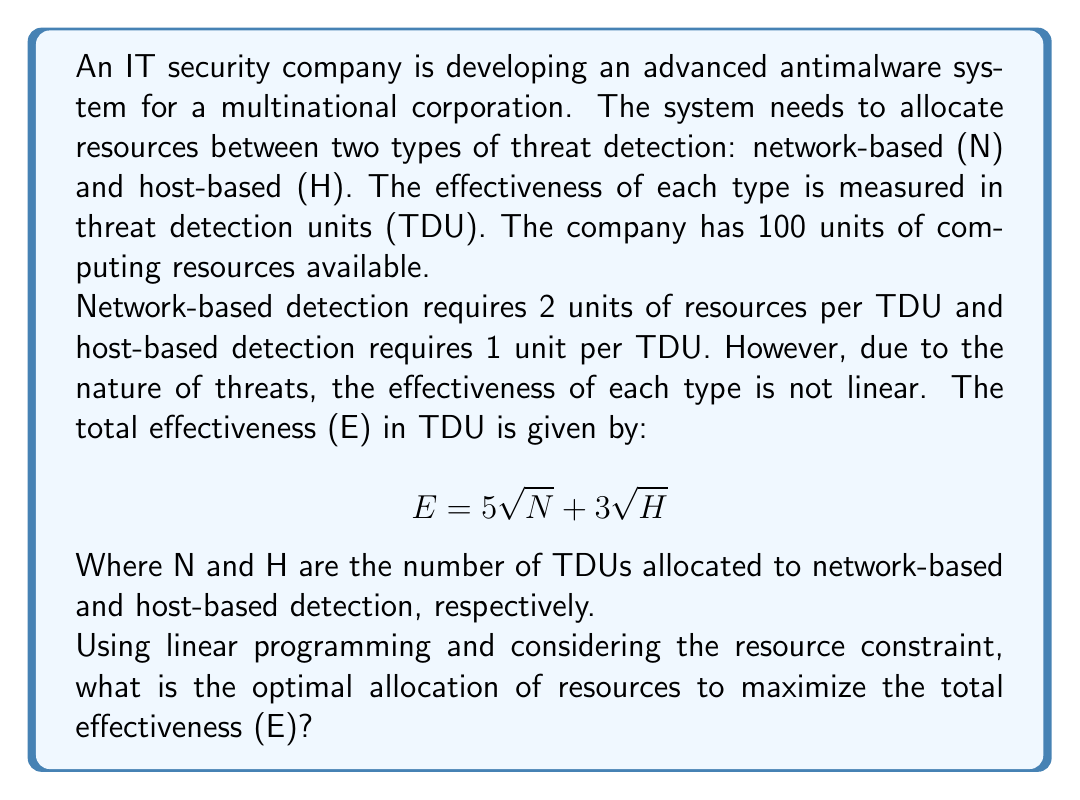Provide a solution to this math problem. To solve this problem, we need to formulate it as a linear programming problem and then solve it. Let's approach this step-by-step:

1) First, let's define our variables:
   N = number of TDUs for network-based detection
   H = number of TDUs for host-based detection

2) Our objective function is:
   $$ E = 5\sqrt{N} + 3\sqrt{H} $$

3) Our constraint is:
   $$ 2N + H \leq 100 $$
   (because network-based detection uses 2 units per TDU, host-based uses 1 unit, and total resources are 100)

4) We also have non-negativity constraints:
   $$ N \geq 0, H \geq 0 $$

5) This is not a linear programming problem yet because of the square roots. To linearize it, we can introduce new variables:
   Let $x = \sqrt{N}$ and $y = \sqrt{H}$

6) Now our problem becomes:
   Maximize $E = 5x + 3y$
   Subject to: $2x^2 + y^2 \leq 100$
               $x \geq 0, y \geq 0$

7) This is now a nonlinear programming problem. We can solve it using the method of Lagrange multipliers:

   $L(x,y,\lambda) = 5x + 3y + \lambda(100 - 2x^2 - y^2)$

8) Taking partial derivatives and setting them to zero:

   $\frac{\partial L}{\partial x} = 5 - 4\lambda x = 0$
   $\frac{\partial L}{\partial y} = 3 - 2\lambda y = 0$
   $\frac{\partial L}{\partial \lambda} = 100 - 2x^2 - y^2 = 0$

9) From the first two equations:
   $x = \frac{5}{4\lambda}$ and $y = \frac{3}{2\lambda}$

10) Substituting these into the third equation:

    $100 - 2(\frac{5}{4\lambda})^2 - (\frac{3}{2\lambda})^2 = 0$

11) Solving this equation:
    $\lambda = \frac{1}{2}$

12) Therefore:
    $x = \frac{5}{4(\frac{1}{2})} = 2.5$
    $y = \frac{3}{2(\frac{1}{2})} = 3$

13) Returning to our original variables:
    $N = x^2 = 6.25$
    $H = y^2 = 9$

14) Rounding to the nearest whole number (as we can't have fractional TDUs):
    $N = 6$ and $H = 9$

Therefore, the optimal allocation is 6 TDUs for network-based detection and 9 TDUs for host-based detection.
Answer: The optimal allocation is 6 TDUs for network-based detection and 9 TDUs for host-based detection, resulting in a total effectiveness of $5\sqrt{6} + 3\sqrt{9} \approx 21.25$ TDUs. 